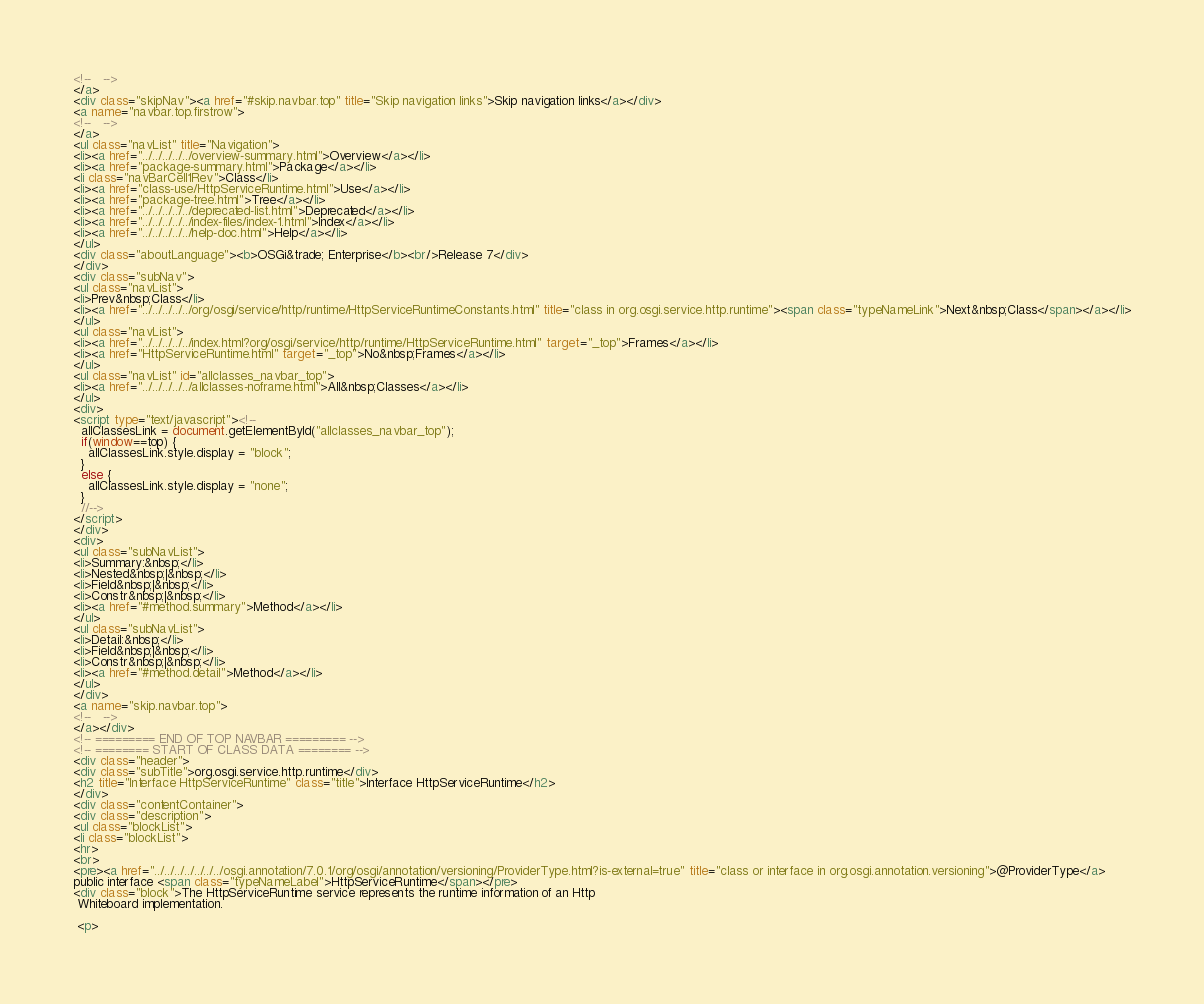Convert code to text. <code><loc_0><loc_0><loc_500><loc_500><_HTML_><!--   -->
</a>
<div class="skipNav"><a href="#skip.navbar.top" title="Skip navigation links">Skip navigation links</a></div>
<a name="navbar.top.firstrow">
<!--   -->
</a>
<ul class="navList" title="Navigation">
<li><a href="../../../../../overview-summary.html">Overview</a></li>
<li><a href="package-summary.html">Package</a></li>
<li class="navBarCell1Rev">Class</li>
<li><a href="class-use/HttpServiceRuntime.html">Use</a></li>
<li><a href="package-tree.html">Tree</a></li>
<li><a href="../../../../../deprecated-list.html">Deprecated</a></li>
<li><a href="../../../../../index-files/index-1.html">Index</a></li>
<li><a href="../../../../../help-doc.html">Help</a></li>
</ul>
<div class="aboutLanguage"><b>OSGi&trade; Enterprise</b><br/>Release 7</div>
</div>
<div class="subNav">
<ul class="navList">
<li>Prev&nbsp;Class</li>
<li><a href="../../../../../org/osgi/service/http/runtime/HttpServiceRuntimeConstants.html" title="class in org.osgi.service.http.runtime"><span class="typeNameLink">Next&nbsp;Class</span></a></li>
</ul>
<ul class="navList">
<li><a href="../../../../../index.html?org/osgi/service/http/runtime/HttpServiceRuntime.html" target="_top">Frames</a></li>
<li><a href="HttpServiceRuntime.html" target="_top">No&nbsp;Frames</a></li>
</ul>
<ul class="navList" id="allclasses_navbar_top">
<li><a href="../../../../../allclasses-noframe.html">All&nbsp;Classes</a></li>
</ul>
<div>
<script type="text/javascript"><!--
  allClassesLink = document.getElementById("allclasses_navbar_top");
  if(window==top) {
    allClassesLink.style.display = "block";
  }
  else {
    allClassesLink.style.display = "none";
  }
  //-->
</script>
</div>
<div>
<ul class="subNavList">
<li>Summary:&nbsp;</li>
<li>Nested&nbsp;|&nbsp;</li>
<li>Field&nbsp;|&nbsp;</li>
<li>Constr&nbsp;|&nbsp;</li>
<li><a href="#method.summary">Method</a></li>
</ul>
<ul class="subNavList">
<li>Detail:&nbsp;</li>
<li>Field&nbsp;|&nbsp;</li>
<li>Constr&nbsp;|&nbsp;</li>
<li><a href="#method.detail">Method</a></li>
</ul>
</div>
<a name="skip.navbar.top">
<!--   -->
</a></div>
<!-- ========= END OF TOP NAVBAR ========= -->
<!-- ======== START OF CLASS DATA ======== -->
<div class="header">
<div class="subTitle">org.osgi.service.http.runtime</div>
<h2 title="Interface HttpServiceRuntime" class="title">Interface HttpServiceRuntime</h2>
</div>
<div class="contentContainer">
<div class="description">
<ul class="blockList">
<li class="blockList">
<hr>
<br>
<pre><a href="../../../../../../../osgi.annotation/7.0.1/org/osgi/annotation/versioning/ProviderType.html?is-external=true" title="class or interface in org.osgi.annotation.versioning">@ProviderType</a>
public interface <span class="typeNameLabel">HttpServiceRuntime</span></pre>
<div class="block">The HttpServiceRuntime service represents the runtime information of an Http
 Whiteboard implementation.

 <p></code> 